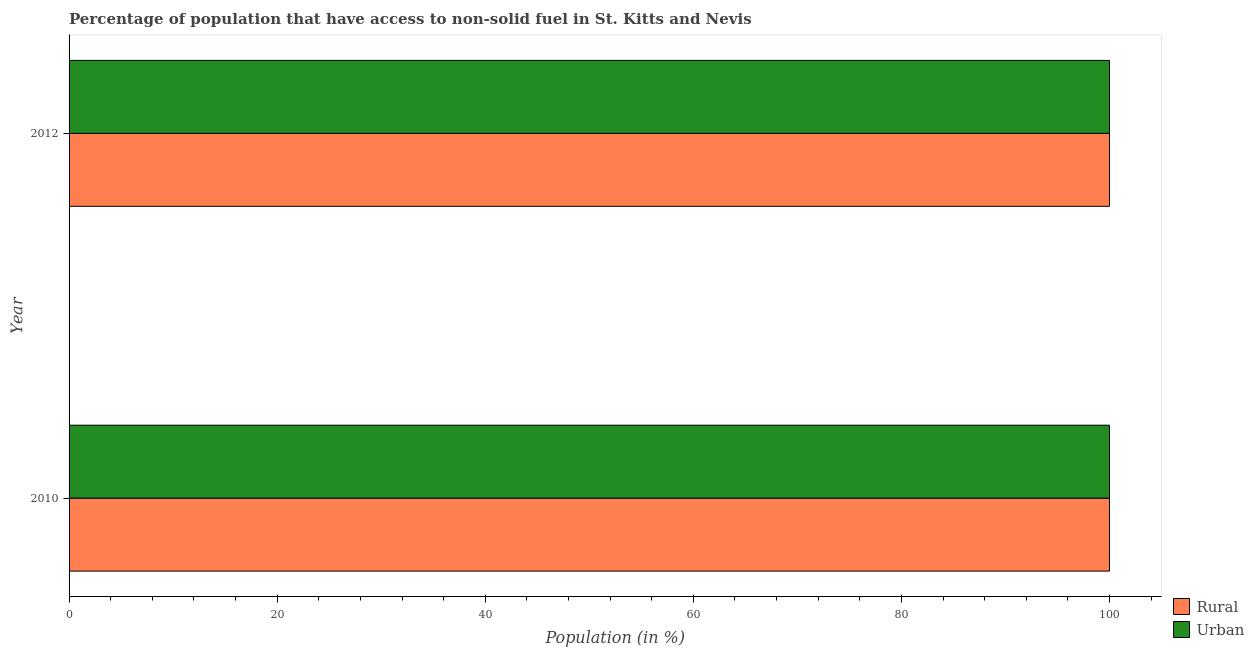How many different coloured bars are there?
Give a very brief answer. 2. How many groups of bars are there?
Provide a short and direct response. 2. Are the number of bars on each tick of the Y-axis equal?
Keep it short and to the point. Yes. How many bars are there on the 2nd tick from the top?
Your answer should be compact. 2. What is the label of the 1st group of bars from the top?
Give a very brief answer. 2012. What is the urban population in 2010?
Give a very brief answer. 100. Across all years, what is the maximum urban population?
Your answer should be very brief. 100. Across all years, what is the minimum urban population?
Give a very brief answer. 100. What is the total rural population in the graph?
Your answer should be very brief. 200. What is the difference between the urban population in 2010 and that in 2012?
Provide a succinct answer. 0. In the year 2010, what is the difference between the urban population and rural population?
Provide a succinct answer. 0. What is the ratio of the urban population in 2010 to that in 2012?
Provide a short and direct response. 1. What does the 1st bar from the top in 2012 represents?
Your answer should be very brief. Urban. What does the 2nd bar from the bottom in 2010 represents?
Your answer should be compact. Urban. Are all the bars in the graph horizontal?
Your answer should be very brief. Yes. Are the values on the major ticks of X-axis written in scientific E-notation?
Make the answer very short. No. Does the graph contain any zero values?
Provide a succinct answer. No. Does the graph contain grids?
Keep it short and to the point. No. What is the title of the graph?
Make the answer very short. Percentage of population that have access to non-solid fuel in St. Kitts and Nevis. What is the label or title of the Y-axis?
Ensure brevity in your answer.  Year. What is the Population (in %) in Urban in 2010?
Ensure brevity in your answer.  100. What is the Population (in %) of Urban in 2012?
Offer a terse response. 100. Across all years, what is the maximum Population (in %) of Rural?
Offer a very short reply. 100. Across all years, what is the minimum Population (in %) in Urban?
Keep it short and to the point. 100. What is the total Population (in %) of Rural in the graph?
Offer a terse response. 200. What is the total Population (in %) in Urban in the graph?
Ensure brevity in your answer.  200. What is the difference between the Population (in %) in Rural in 2010 and that in 2012?
Ensure brevity in your answer.  0. What is the difference between the Population (in %) in Rural in 2010 and the Population (in %) in Urban in 2012?
Your response must be concise. 0. What is the average Population (in %) of Rural per year?
Your response must be concise. 100. In the year 2012, what is the difference between the Population (in %) of Rural and Population (in %) of Urban?
Give a very brief answer. 0. What is the ratio of the Population (in %) of Rural in 2010 to that in 2012?
Keep it short and to the point. 1. What is the difference between the highest and the second highest Population (in %) in Urban?
Provide a succinct answer. 0. 